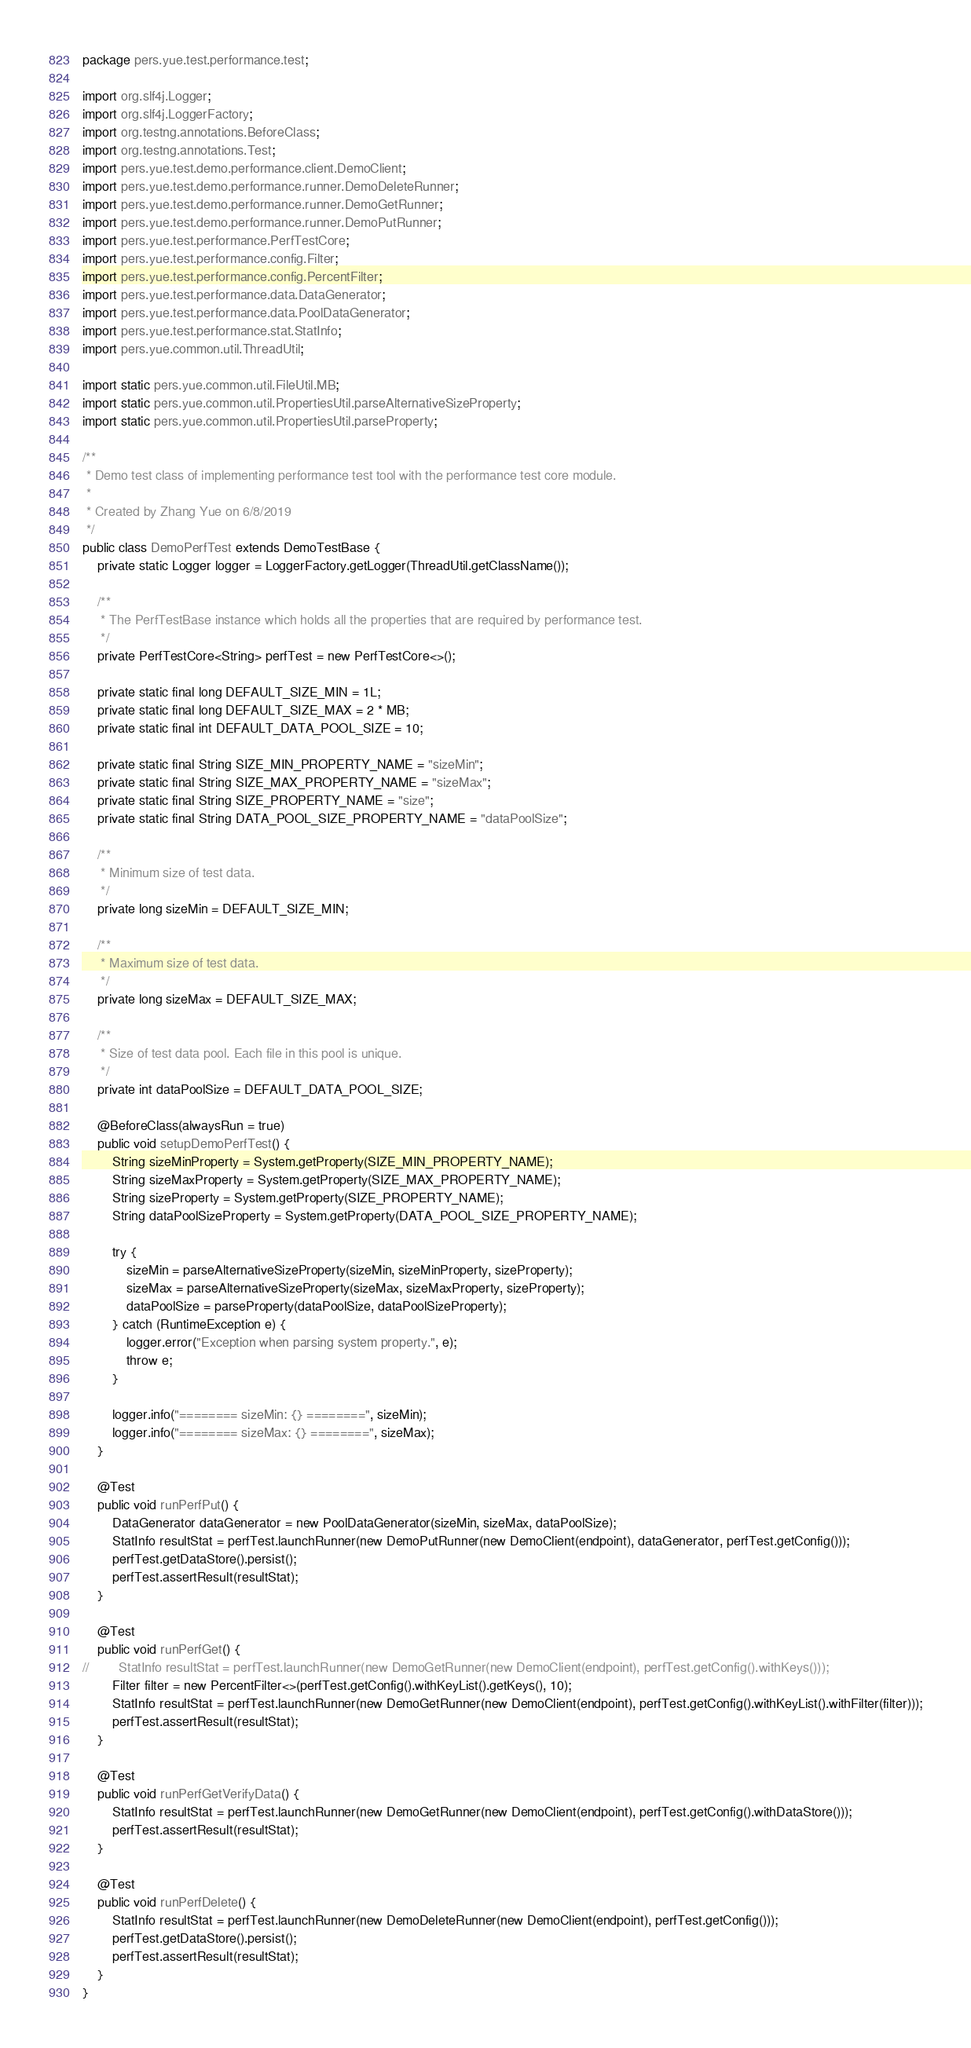Convert code to text. <code><loc_0><loc_0><loc_500><loc_500><_Java_>package pers.yue.test.performance.test;

import org.slf4j.Logger;
import org.slf4j.LoggerFactory;
import org.testng.annotations.BeforeClass;
import org.testng.annotations.Test;
import pers.yue.test.demo.performance.client.DemoClient;
import pers.yue.test.demo.performance.runner.DemoDeleteRunner;
import pers.yue.test.demo.performance.runner.DemoGetRunner;
import pers.yue.test.demo.performance.runner.DemoPutRunner;
import pers.yue.test.performance.PerfTestCore;
import pers.yue.test.performance.config.Filter;
import pers.yue.test.performance.config.PercentFilter;
import pers.yue.test.performance.data.DataGenerator;
import pers.yue.test.performance.data.PoolDataGenerator;
import pers.yue.test.performance.stat.StatInfo;
import pers.yue.common.util.ThreadUtil;

import static pers.yue.common.util.FileUtil.MB;
import static pers.yue.common.util.PropertiesUtil.parseAlternativeSizeProperty;
import static pers.yue.common.util.PropertiesUtil.parseProperty;

/**
 * Demo test class of implementing performance test tool with the performance test core module.
 *
 * Created by Zhang Yue on 6/8/2019
 */
public class DemoPerfTest extends DemoTestBase {
    private static Logger logger = LoggerFactory.getLogger(ThreadUtil.getClassName());

    /**
     * The PerfTestBase instance which holds all the properties that are required by performance test.
     */
    private PerfTestCore<String> perfTest = new PerfTestCore<>();

    private static final long DEFAULT_SIZE_MIN = 1L;
    private static final long DEFAULT_SIZE_MAX = 2 * MB;
    private static final int DEFAULT_DATA_POOL_SIZE = 10;

    private static final String SIZE_MIN_PROPERTY_NAME = "sizeMin";
    private static final String SIZE_MAX_PROPERTY_NAME = "sizeMax";
    private static final String SIZE_PROPERTY_NAME = "size";
    private static final String DATA_POOL_SIZE_PROPERTY_NAME = "dataPoolSize";

    /**
     * Minimum size of test data.
     */
    private long sizeMin = DEFAULT_SIZE_MIN;

    /**
     * Maximum size of test data.
     */
    private long sizeMax = DEFAULT_SIZE_MAX;

    /**
     * Size of test data pool. Each file in this pool is unique.
     */
    private int dataPoolSize = DEFAULT_DATA_POOL_SIZE;

    @BeforeClass(alwaysRun = true)
    public void setupDemoPerfTest() {
        String sizeMinProperty = System.getProperty(SIZE_MIN_PROPERTY_NAME);
        String sizeMaxProperty = System.getProperty(SIZE_MAX_PROPERTY_NAME);
        String sizeProperty = System.getProperty(SIZE_PROPERTY_NAME);
        String dataPoolSizeProperty = System.getProperty(DATA_POOL_SIZE_PROPERTY_NAME);

        try {
            sizeMin = parseAlternativeSizeProperty(sizeMin, sizeMinProperty, sizeProperty);
            sizeMax = parseAlternativeSizeProperty(sizeMax, sizeMaxProperty, sizeProperty);
            dataPoolSize = parseProperty(dataPoolSize, dataPoolSizeProperty);
        } catch (RuntimeException e) {
            logger.error("Exception when parsing system property.", e);
            throw e;
        }

        logger.info("======== sizeMin: {} ========", sizeMin);
        logger.info("======== sizeMax: {} ========", sizeMax);
    }

    @Test
    public void runPerfPut() {
        DataGenerator dataGenerator = new PoolDataGenerator(sizeMin, sizeMax, dataPoolSize);
        StatInfo resultStat = perfTest.launchRunner(new DemoPutRunner(new DemoClient(endpoint), dataGenerator, perfTest.getConfig()));
        perfTest.getDataStore().persist();
        perfTest.assertResult(resultStat);
    }

    @Test
    public void runPerfGet() {
//        StatInfo resultStat = perfTest.launchRunner(new DemoGetRunner(new DemoClient(endpoint), perfTest.getConfig().withKeys()));
        Filter filter = new PercentFilter<>(perfTest.getConfig().withKeyList().getKeys(), 10);
        StatInfo resultStat = perfTest.launchRunner(new DemoGetRunner(new DemoClient(endpoint), perfTest.getConfig().withKeyList().withFilter(filter)));
        perfTest.assertResult(resultStat);
    }

    @Test
    public void runPerfGetVerifyData() {
        StatInfo resultStat = perfTest.launchRunner(new DemoGetRunner(new DemoClient(endpoint), perfTest.getConfig().withDataStore()));
        perfTest.assertResult(resultStat);
    }

    @Test
    public void runPerfDelete() {
        StatInfo resultStat = perfTest.launchRunner(new DemoDeleteRunner(new DemoClient(endpoint), perfTest.getConfig()));
        perfTest.getDataStore().persist();
        perfTest.assertResult(resultStat);
    }
}
</code> 